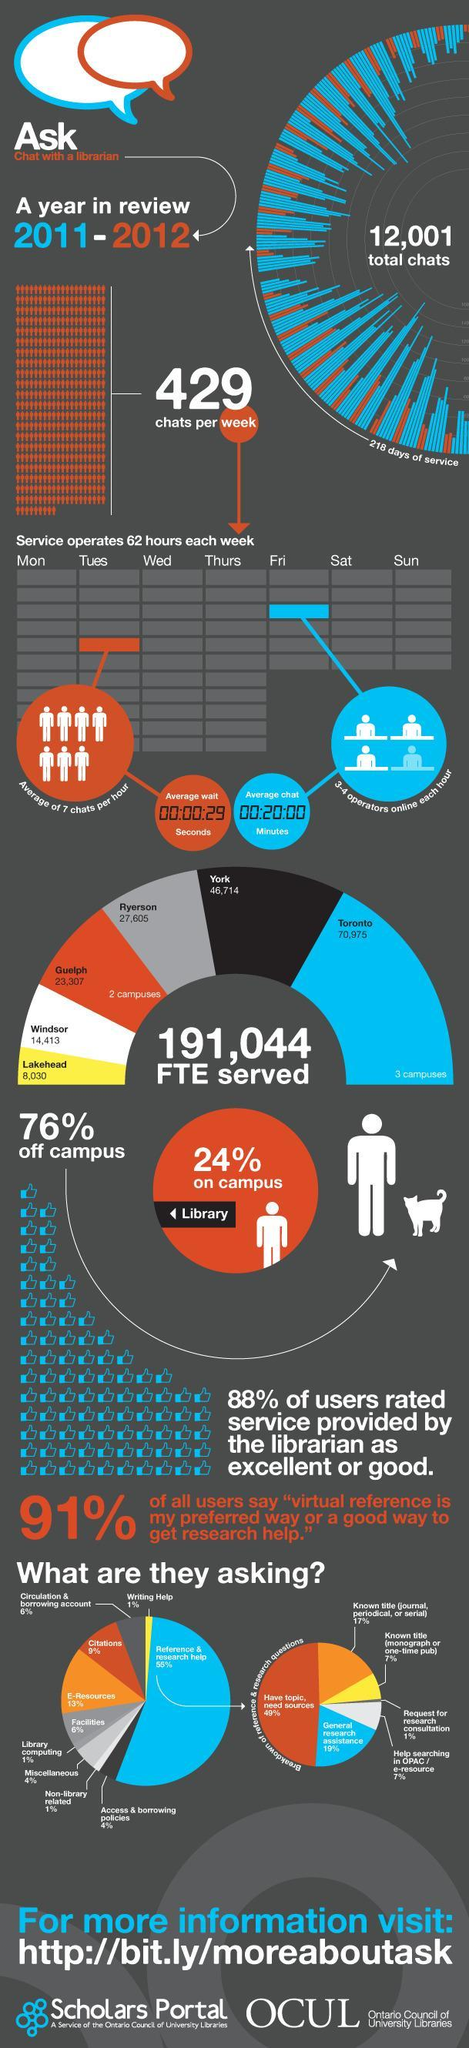What percentage represents the third most asked in reference and research help?
Answer the question with a short phrase. 17% Which color represents York, blue or black? black What represents the third most asked in reference and research help? Known title (journal,periodical or serial) What percentage represents the most asked in reference and research help? 49% How many FTEs are served in Toronto and York combined? 117,689 How many FTEs are served in Toronto and Lakehead combined? 79,005 Which color represents Windsor, white, blue or black? white Which color represents Lakehead, blue, black or yellow? yellow What represents the most asked in reference and research help? have topic, need sources What is the second most asked service to a librarian? E-Resources Which color represents the second most asked, black, orange or blue? orange Which color represents the most asked, black, orange or blue? blue 